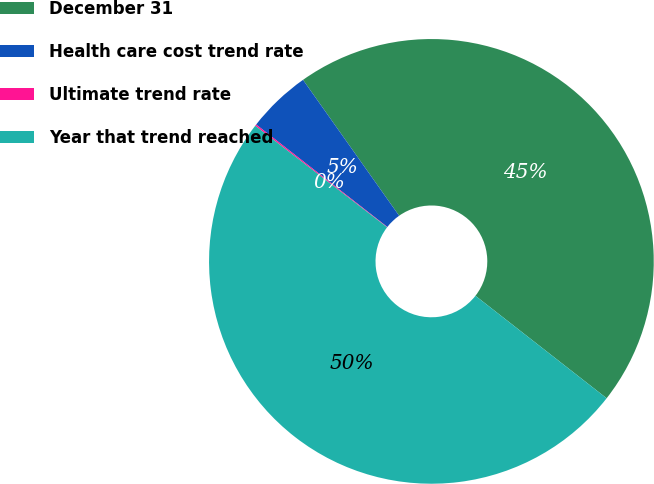Convert chart. <chart><loc_0><loc_0><loc_500><loc_500><pie_chart><fcel>December 31<fcel>Health care cost trend rate<fcel>Ultimate trend rate<fcel>Year that trend reached<nl><fcel>45.35%<fcel>4.65%<fcel>0.11%<fcel>49.89%<nl></chart> 